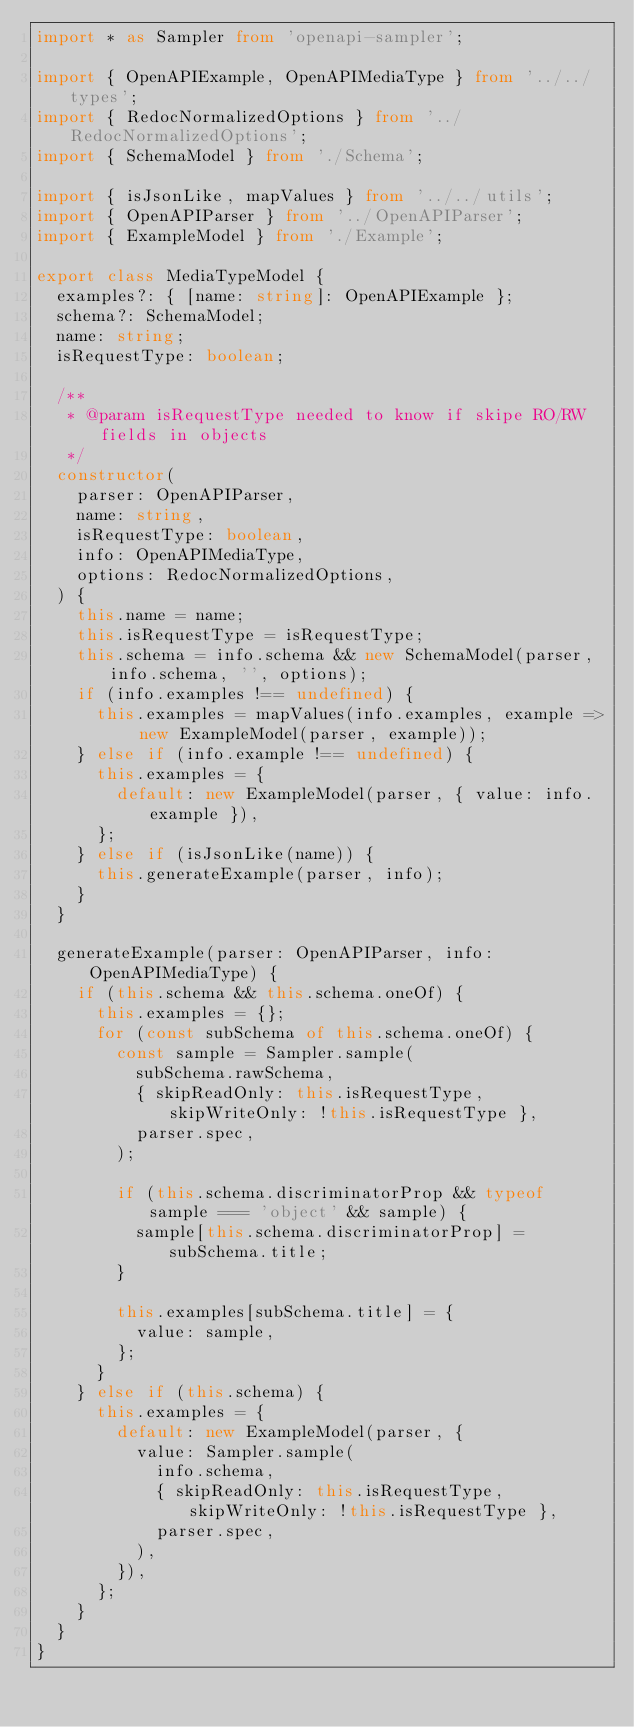<code> <loc_0><loc_0><loc_500><loc_500><_TypeScript_>import * as Sampler from 'openapi-sampler';

import { OpenAPIExample, OpenAPIMediaType } from '../../types';
import { RedocNormalizedOptions } from '../RedocNormalizedOptions';
import { SchemaModel } from './Schema';

import { isJsonLike, mapValues } from '../../utils';
import { OpenAPIParser } from '../OpenAPIParser';
import { ExampleModel } from './Example';

export class MediaTypeModel {
  examples?: { [name: string]: OpenAPIExample };
  schema?: SchemaModel;
  name: string;
  isRequestType: boolean;

  /**
   * @param isRequestType needed to know if skipe RO/RW fields in objects
   */
  constructor(
    parser: OpenAPIParser,
    name: string,
    isRequestType: boolean,
    info: OpenAPIMediaType,
    options: RedocNormalizedOptions,
  ) {
    this.name = name;
    this.isRequestType = isRequestType;
    this.schema = info.schema && new SchemaModel(parser, info.schema, '', options);
    if (info.examples !== undefined) {
      this.examples = mapValues(info.examples, example => new ExampleModel(parser, example));
    } else if (info.example !== undefined) {
      this.examples = {
        default: new ExampleModel(parser, { value: info.example }),
      };
    } else if (isJsonLike(name)) {
      this.generateExample(parser, info);
    }
  }

  generateExample(parser: OpenAPIParser, info: OpenAPIMediaType) {
    if (this.schema && this.schema.oneOf) {
      this.examples = {};
      for (const subSchema of this.schema.oneOf) {
        const sample = Sampler.sample(
          subSchema.rawSchema,
          { skipReadOnly: this.isRequestType, skipWriteOnly: !this.isRequestType },
          parser.spec,
        );

        if (this.schema.discriminatorProp && typeof sample === 'object' && sample) {
          sample[this.schema.discriminatorProp] = subSchema.title;
        }

        this.examples[subSchema.title] = {
          value: sample,
        };
      }
    } else if (this.schema) {
      this.examples = {
        default: new ExampleModel(parser, {
          value: Sampler.sample(
            info.schema,
            { skipReadOnly: this.isRequestType, skipWriteOnly: !this.isRequestType },
            parser.spec,
          ),
        }),
      };
    }
  }
}
</code> 